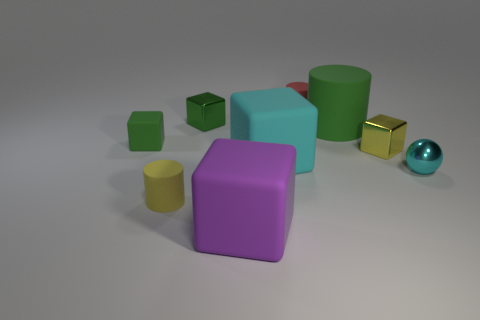Can you describe the shapes in the image? Certainly! The image features a variety of geometric shapes: there's a large matte cylinder, a few cubes, a smaller cylinder, a sphere, and what looks to be a rectangular prism with chamfered edges. Are the shapes positioned in a certain pattern? They don't appear to follow a specific pattern, but rather are scattered randomly across the surface, creating a casual and unstructured arrangement. 